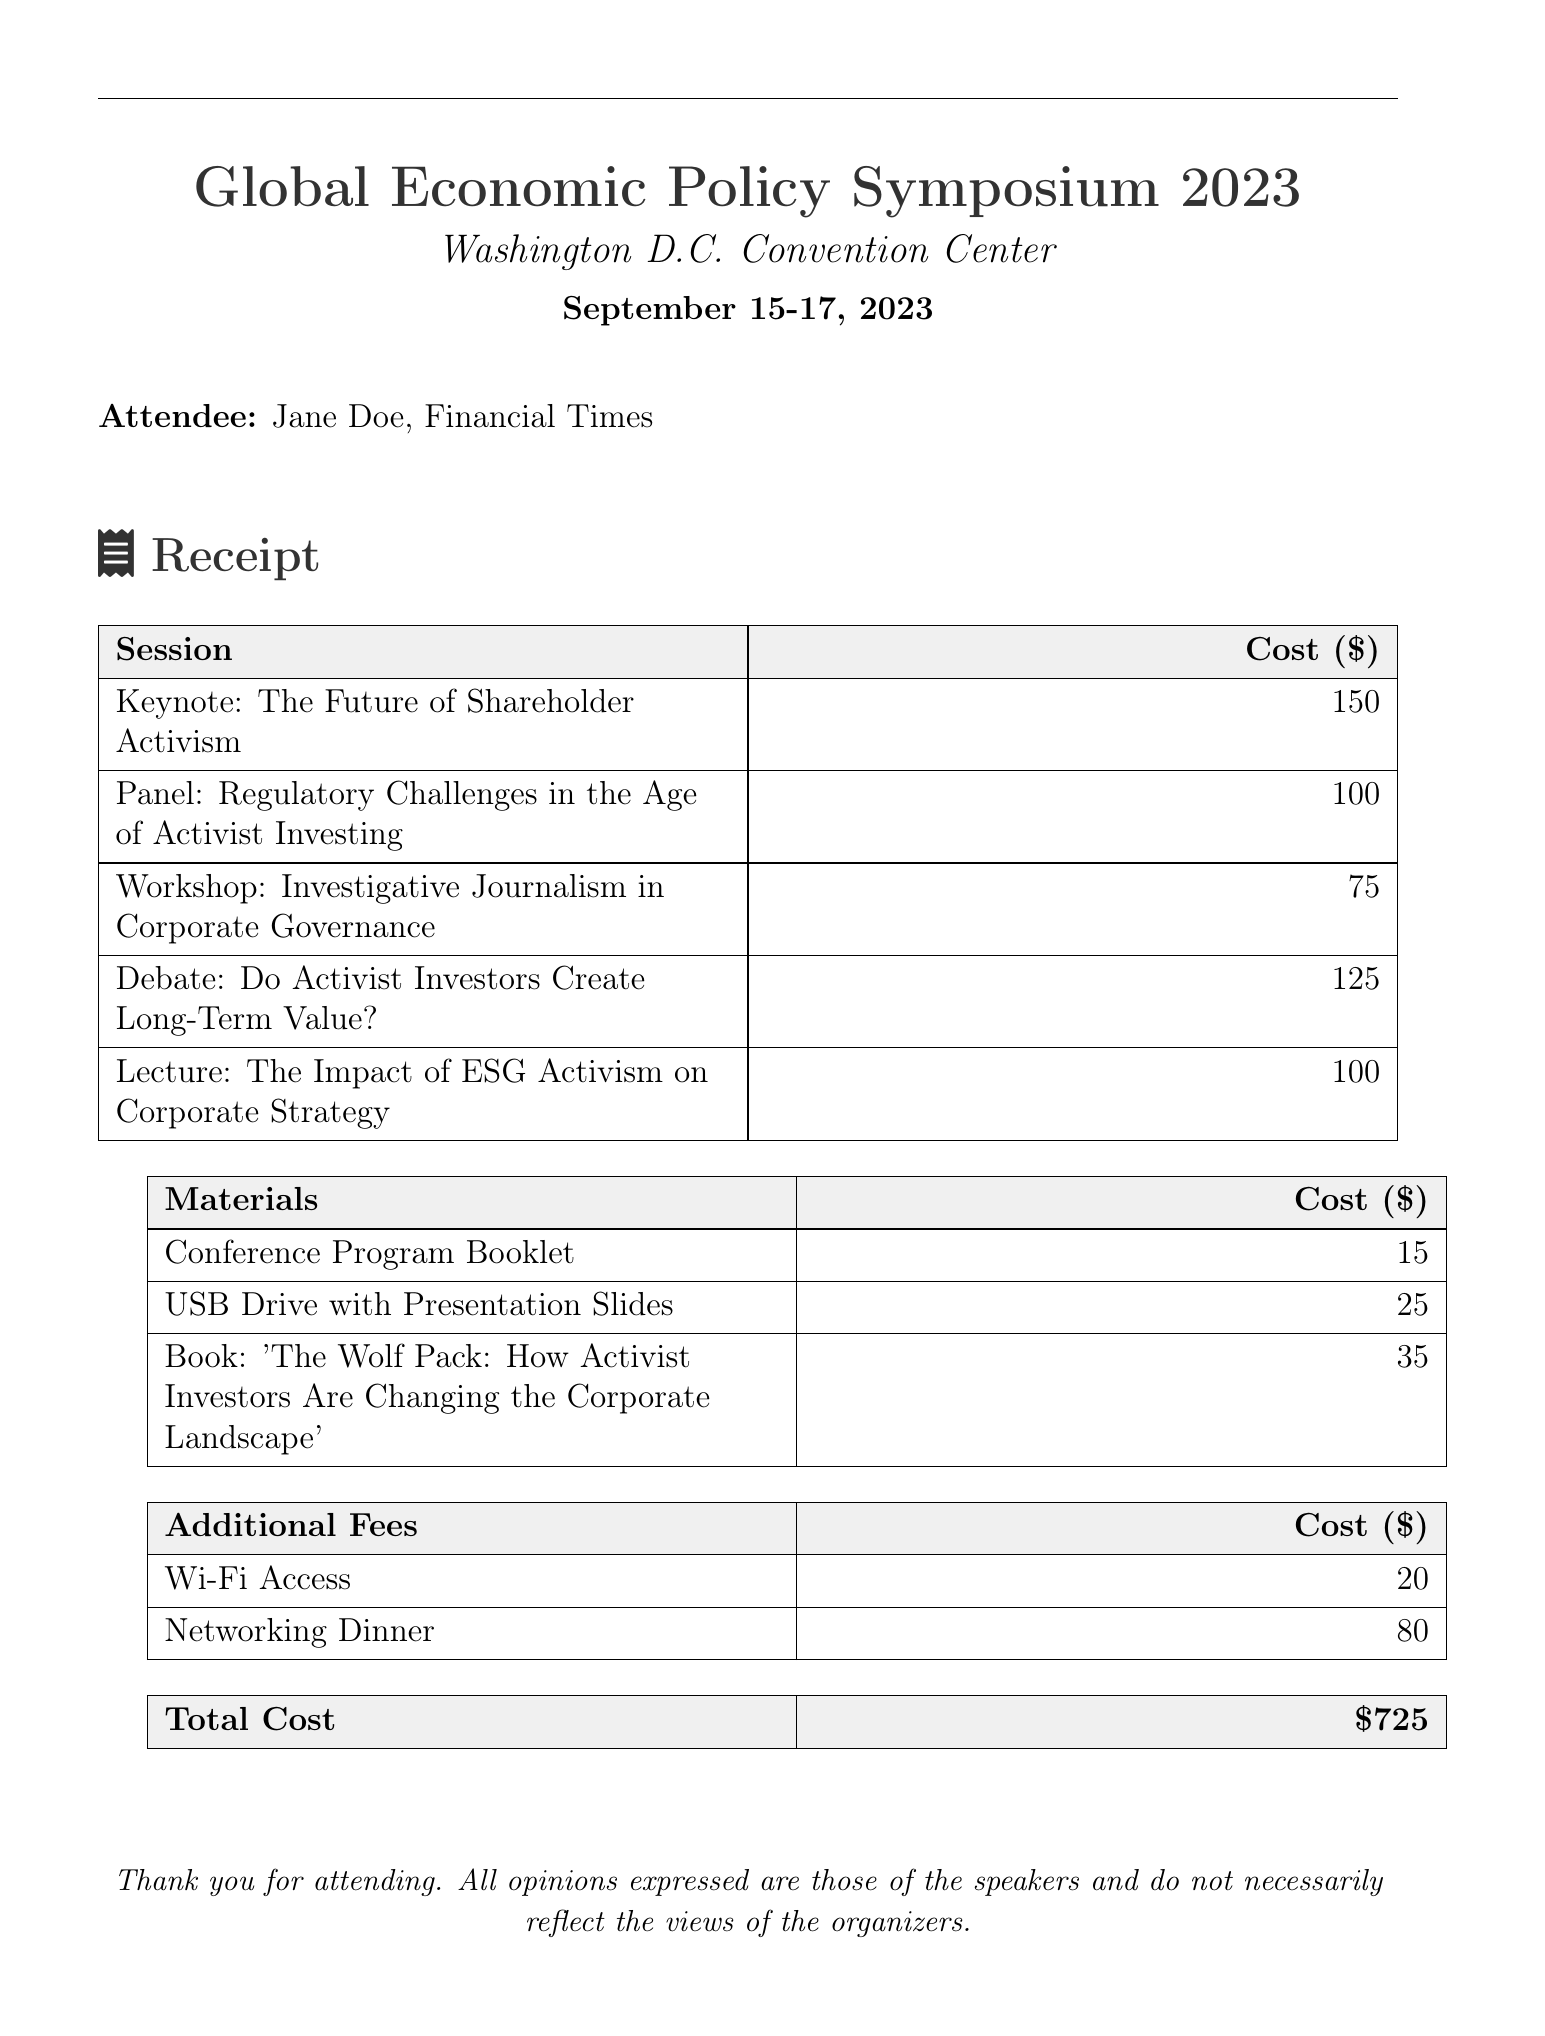What is the conference title? The conference title is listed at the beginning of the document.
Answer: Global Economic Policy Symposium 2023 What is the location of the conference? The location is stated directly after the title of the conference.
Answer: Washington D.C. Convention Center Who is the keynote speaker? The keynote speaker's name is mentioned in the session details.
Answer: Carl Icahn How much does the workshop cost? The cost of the workshop is specified in the session costs table.
Answer: 75 What is the cost of the Conference Program Booklet? The cost of this material is found in the materials table.
Answer: 15 Which session has the highest cost? To answer this, we need to compare all session costs listed in the table.
Answer: Keynote: The Future of Shareholder Activism What is the total cost of attendance? The total cost is presented in the final table of the document.
Answer: 725 How many individual sessions were attended? The number of sessions can be determined by counting the entries in the sessions table.
Answer: 5 What is the cost of Wi-Fi access? The cost of Wi-Fi access is specified in the additional fees section.
Answer: 20 Which additional fee is the highest? This requires comparing the costs listed in the additional fees table.
Answer: Networking Dinner 